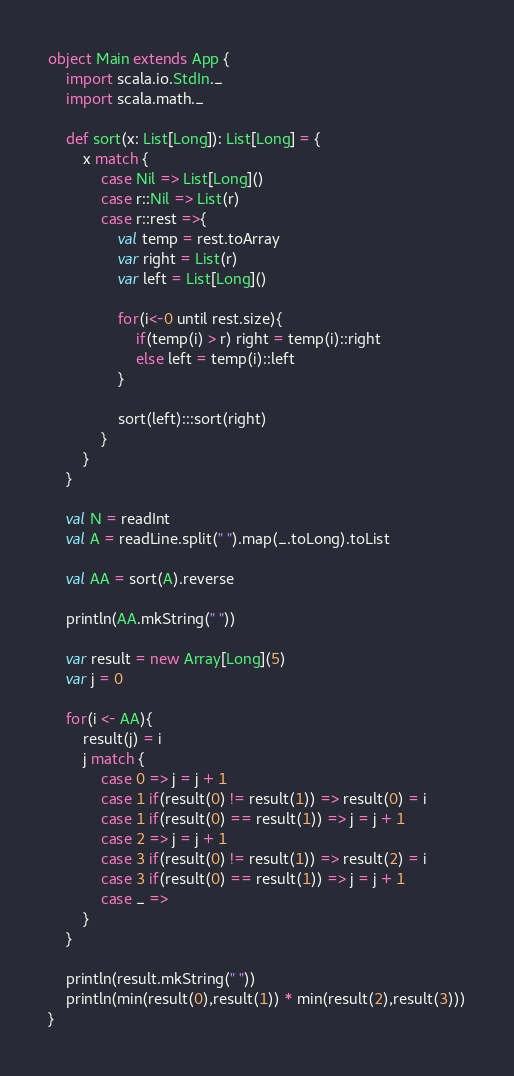<code> <loc_0><loc_0><loc_500><loc_500><_Scala_>object Main extends App {
	import scala.io.StdIn._
	import scala.math._

	def sort(x: List[Long]): List[Long] = {
		x match {
			case Nil => List[Long]()
			case r::Nil => List(r)
			case r::rest =>{
				val temp = rest.toArray
				var right = List(r)
				var left = List[Long]()

				for(i<-0 until rest.size){
					if(temp(i) > r) right = temp(i)::right
					else left = temp(i)::left
				}

				sort(left):::sort(right)
			}
		}
	}
	
	val N = readInt
	val A = readLine.split(" ").map(_.toLong).toList

	val AA = sort(A).reverse

	println(AA.mkString(" "))

	var result = new Array[Long](5)
	var j = 0

	for(i <- AA){
		result(j) = i
		j match {
			case 0 => j = j + 1
			case 1 if(result(0) != result(1)) => result(0) = i
			case 1 if(result(0) == result(1)) => j = j + 1
			case 2 => j = j + 1
			case 3 if(result(0) != result(1)) => result(2) = i
			case 3 if(result(0) == result(1)) => j = j + 1
			case _ => 
		}
	}

	println(result.mkString(" "))
	println(min(result(0),result(1)) * min(result(2),result(3)))
}
</code> 